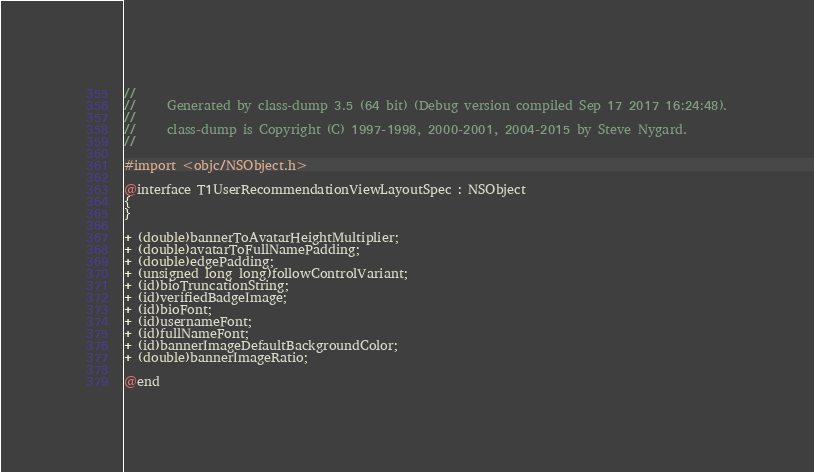Convert code to text. <code><loc_0><loc_0><loc_500><loc_500><_C_>//
//     Generated by class-dump 3.5 (64 bit) (Debug version compiled Sep 17 2017 16:24:48).
//
//     class-dump is Copyright (C) 1997-1998, 2000-2001, 2004-2015 by Steve Nygard.
//

#import <objc/NSObject.h>

@interface T1UserRecommendationViewLayoutSpec : NSObject
{
}

+ (double)bannerToAvatarHeightMultiplier;
+ (double)avatarToFullNamePadding;
+ (double)edgePadding;
+ (unsigned long long)followControlVariant;
+ (id)bioTruncationString;
+ (id)verifiedBadgeImage;
+ (id)bioFont;
+ (id)usernameFont;
+ (id)fullNameFont;
+ (id)bannerImageDefaultBackgroundColor;
+ (double)bannerImageRatio;

@end

</code> 